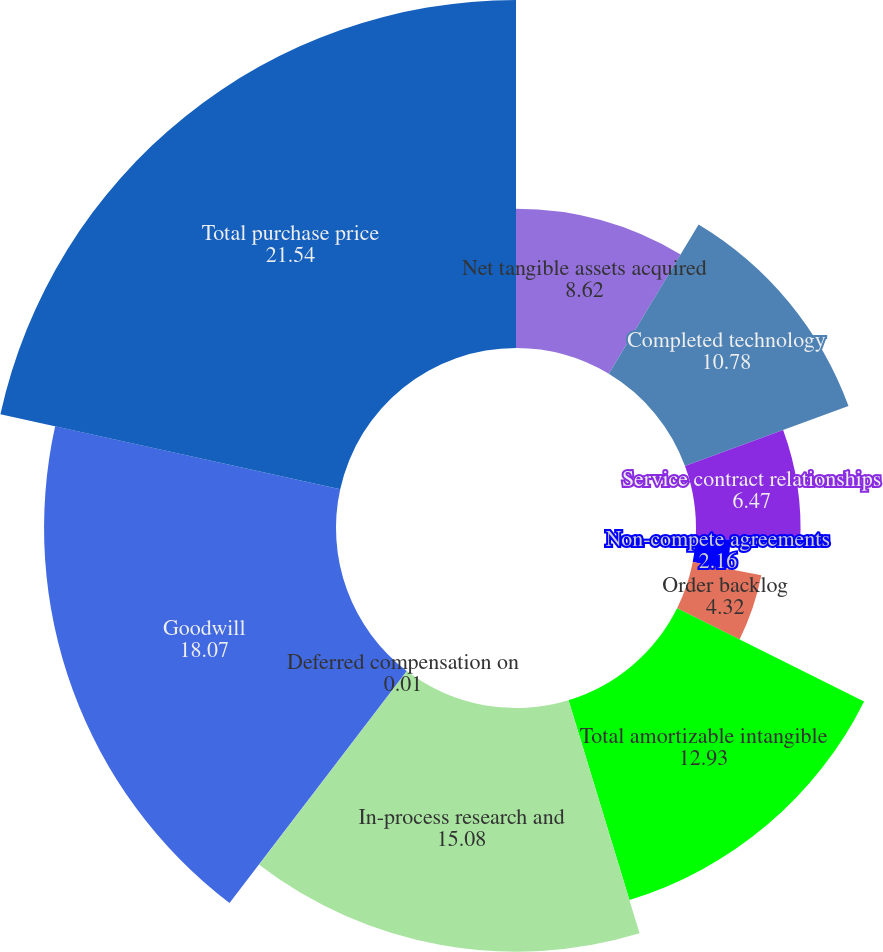<chart> <loc_0><loc_0><loc_500><loc_500><pie_chart><fcel>Net tangible assets acquired<fcel>Completed technology<fcel>Service contract relationships<fcel>Non-compete agreements<fcel>Order backlog<fcel>Total amortizable intangible<fcel>In-process research and<fcel>Deferred compensation on<fcel>Goodwill<fcel>Total purchase price<nl><fcel>8.62%<fcel>10.78%<fcel>6.47%<fcel>2.16%<fcel>4.32%<fcel>12.93%<fcel>15.08%<fcel>0.01%<fcel>18.07%<fcel>21.54%<nl></chart> 